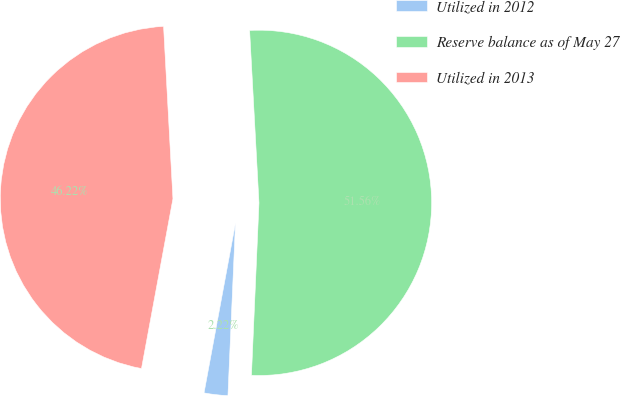<chart> <loc_0><loc_0><loc_500><loc_500><pie_chart><fcel>Utilized in 2012<fcel>Reserve balance as of May 27<fcel>Utilized in 2013<nl><fcel>2.22%<fcel>51.56%<fcel>46.22%<nl></chart> 